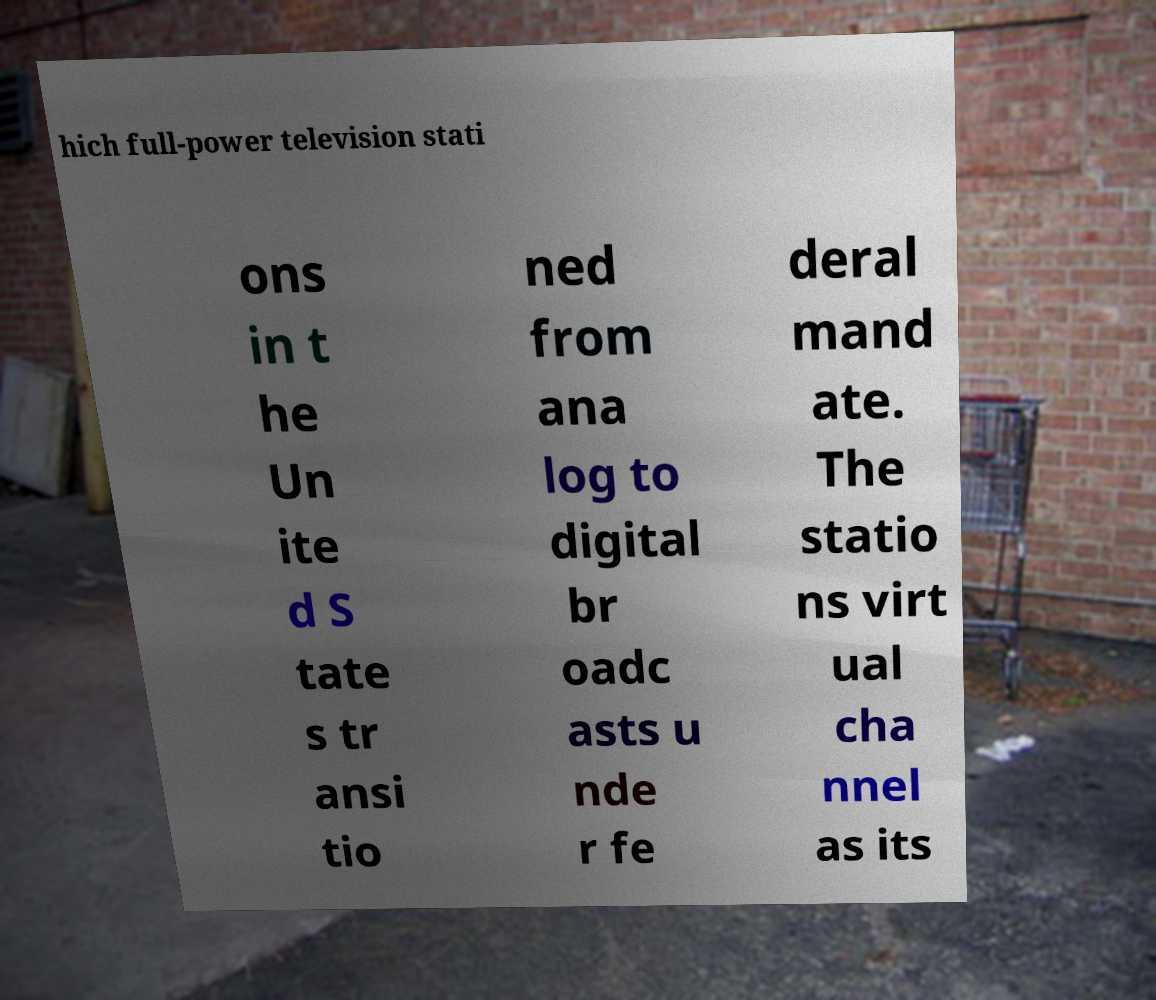Could you extract and type out the text from this image? hich full-power television stati ons in t he Un ite d S tate s tr ansi tio ned from ana log to digital br oadc asts u nde r fe deral mand ate. The statio ns virt ual cha nnel as its 